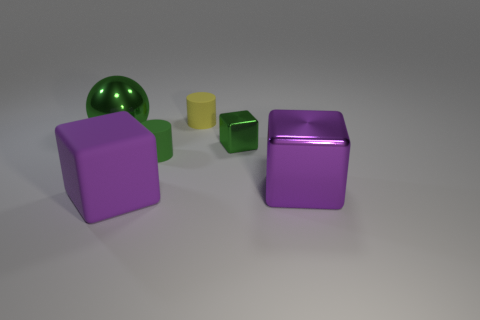Add 3 big purple cylinders. How many objects exist? 9 Subtract all spheres. How many objects are left? 5 Add 2 tiny blue things. How many tiny blue things exist? 2 Subtract 0 cyan cubes. How many objects are left? 6 Subtract all tiny green metallic cubes. Subtract all small metal blocks. How many objects are left? 4 Add 3 big metal things. How many big metal things are left? 5 